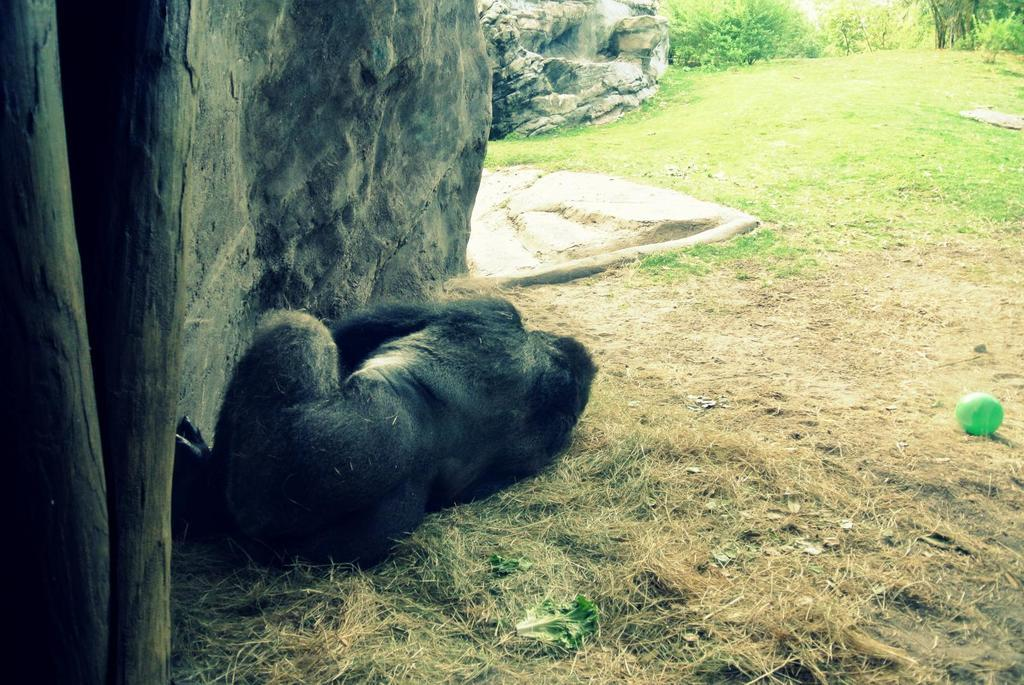What animal is in the image? There is a gorilla in the image. Where is the gorilla located? The gorilla is on the grass. What objects are in front of the gorilla? There are rocks in front of the gorilla. What can be seen in the background of the image? There are trees in the background of the image. What type of stem can be seen growing from the gorilla's head in the image? There is no stem growing from the gorilla's head in the image. 